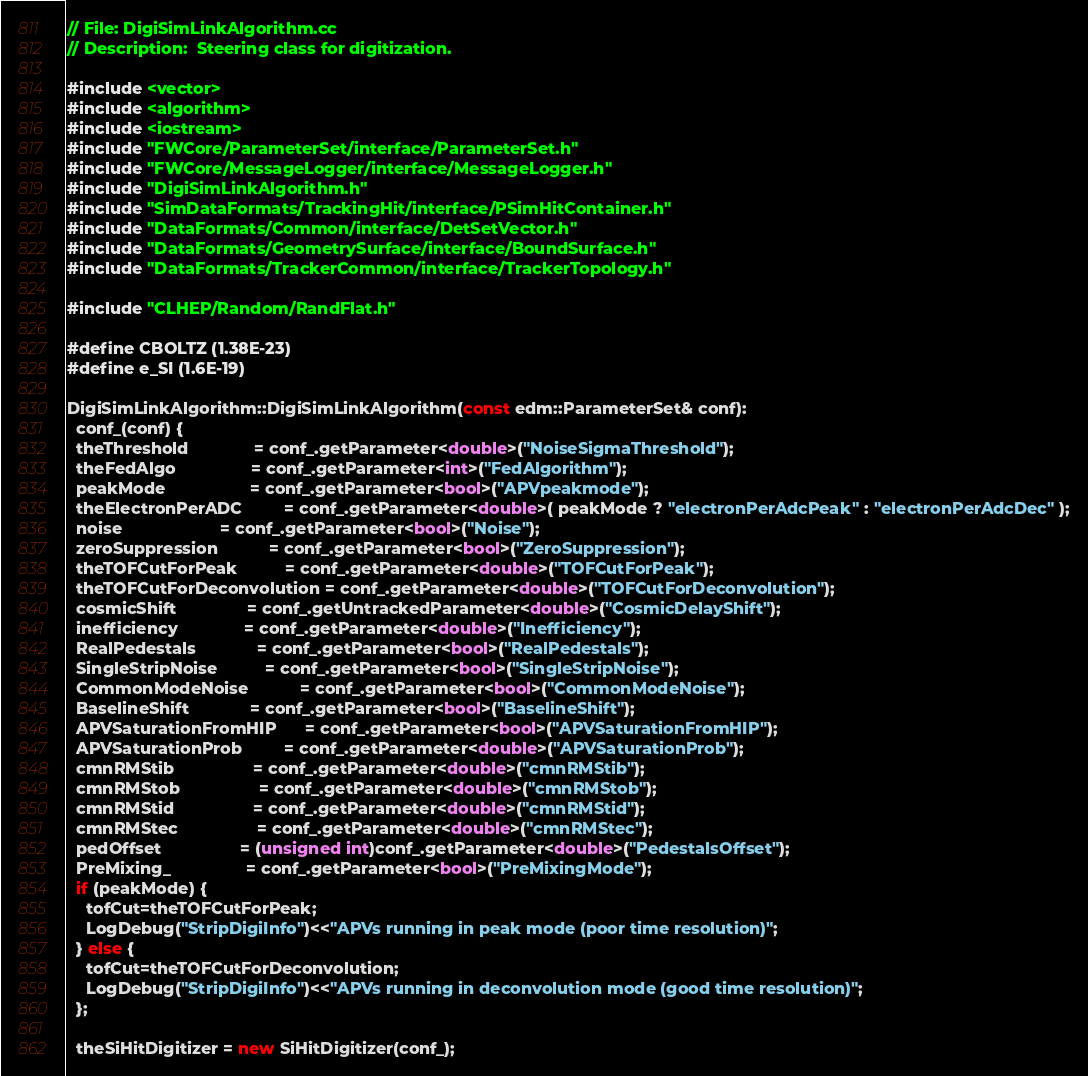<code> <loc_0><loc_0><loc_500><loc_500><_C++_>// File: DigiSimLinkAlgorithm.cc
// Description:  Steering class for digitization.

#include <vector>
#include <algorithm>
#include <iostream>
#include "FWCore/ParameterSet/interface/ParameterSet.h"
#include "FWCore/MessageLogger/interface/MessageLogger.h"
#include "DigiSimLinkAlgorithm.h"
#include "SimDataFormats/TrackingHit/interface/PSimHitContainer.h"
#include "DataFormats/Common/interface/DetSetVector.h"
#include "DataFormats/GeometrySurface/interface/BoundSurface.h"
#include "DataFormats/TrackerCommon/interface/TrackerTopology.h"

#include "CLHEP/Random/RandFlat.h"

#define CBOLTZ (1.38E-23)
#define e_SI (1.6E-19)

DigiSimLinkAlgorithm::DigiSimLinkAlgorithm(const edm::ParameterSet& conf):
  conf_(conf) {
  theThreshold              = conf_.getParameter<double>("NoiseSigmaThreshold");
  theFedAlgo                = conf_.getParameter<int>("FedAlgorithm");
  peakMode                  = conf_.getParameter<bool>("APVpeakmode");
  theElectronPerADC         = conf_.getParameter<double>( peakMode ? "electronPerAdcPeak" : "electronPerAdcDec" );
  noise                     = conf_.getParameter<bool>("Noise");
  zeroSuppression           = conf_.getParameter<bool>("ZeroSuppression");
  theTOFCutForPeak          = conf_.getParameter<double>("TOFCutForPeak");
  theTOFCutForDeconvolution = conf_.getParameter<double>("TOFCutForDeconvolution");
  cosmicShift               = conf_.getUntrackedParameter<double>("CosmicDelayShift");
  inefficiency              = conf_.getParameter<double>("Inefficiency");
  RealPedestals             = conf_.getParameter<bool>("RealPedestals"); 
  SingleStripNoise          = conf_.getParameter<bool>("SingleStripNoise");
  CommonModeNoise           = conf_.getParameter<bool>("CommonModeNoise");
  BaselineShift             = conf_.getParameter<bool>("BaselineShift");
  APVSaturationFromHIP      = conf_.getParameter<bool>("APVSaturationFromHIP");
  APVSaturationProb         = conf_.getParameter<double>("APVSaturationProb");
  cmnRMStib                 = conf_.getParameter<double>("cmnRMStib");
  cmnRMStob                 = conf_.getParameter<double>("cmnRMStob");
  cmnRMStid                 = conf_.getParameter<double>("cmnRMStid");
  cmnRMStec                 = conf_.getParameter<double>("cmnRMStec");
  pedOffset                 = (unsigned int)conf_.getParameter<double>("PedestalsOffset");
  PreMixing_                = conf_.getParameter<bool>("PreMixingMode");
  if (peakMode) {
    tofCut=theTOFCutForPeak;
    LogDebug("StripDigiInfo")<<"APVs running in peak mode (poor time resolution)";
  } else {
    tofCut=theTOFCutForDeconvolution;
    LogDebug("StripDigiInfo")<<"APVs running in deconvolution mode (good time resolution)";
  };
  
  theSiHitDigitizer = new SiHitDigitizer(conf_);</code> 